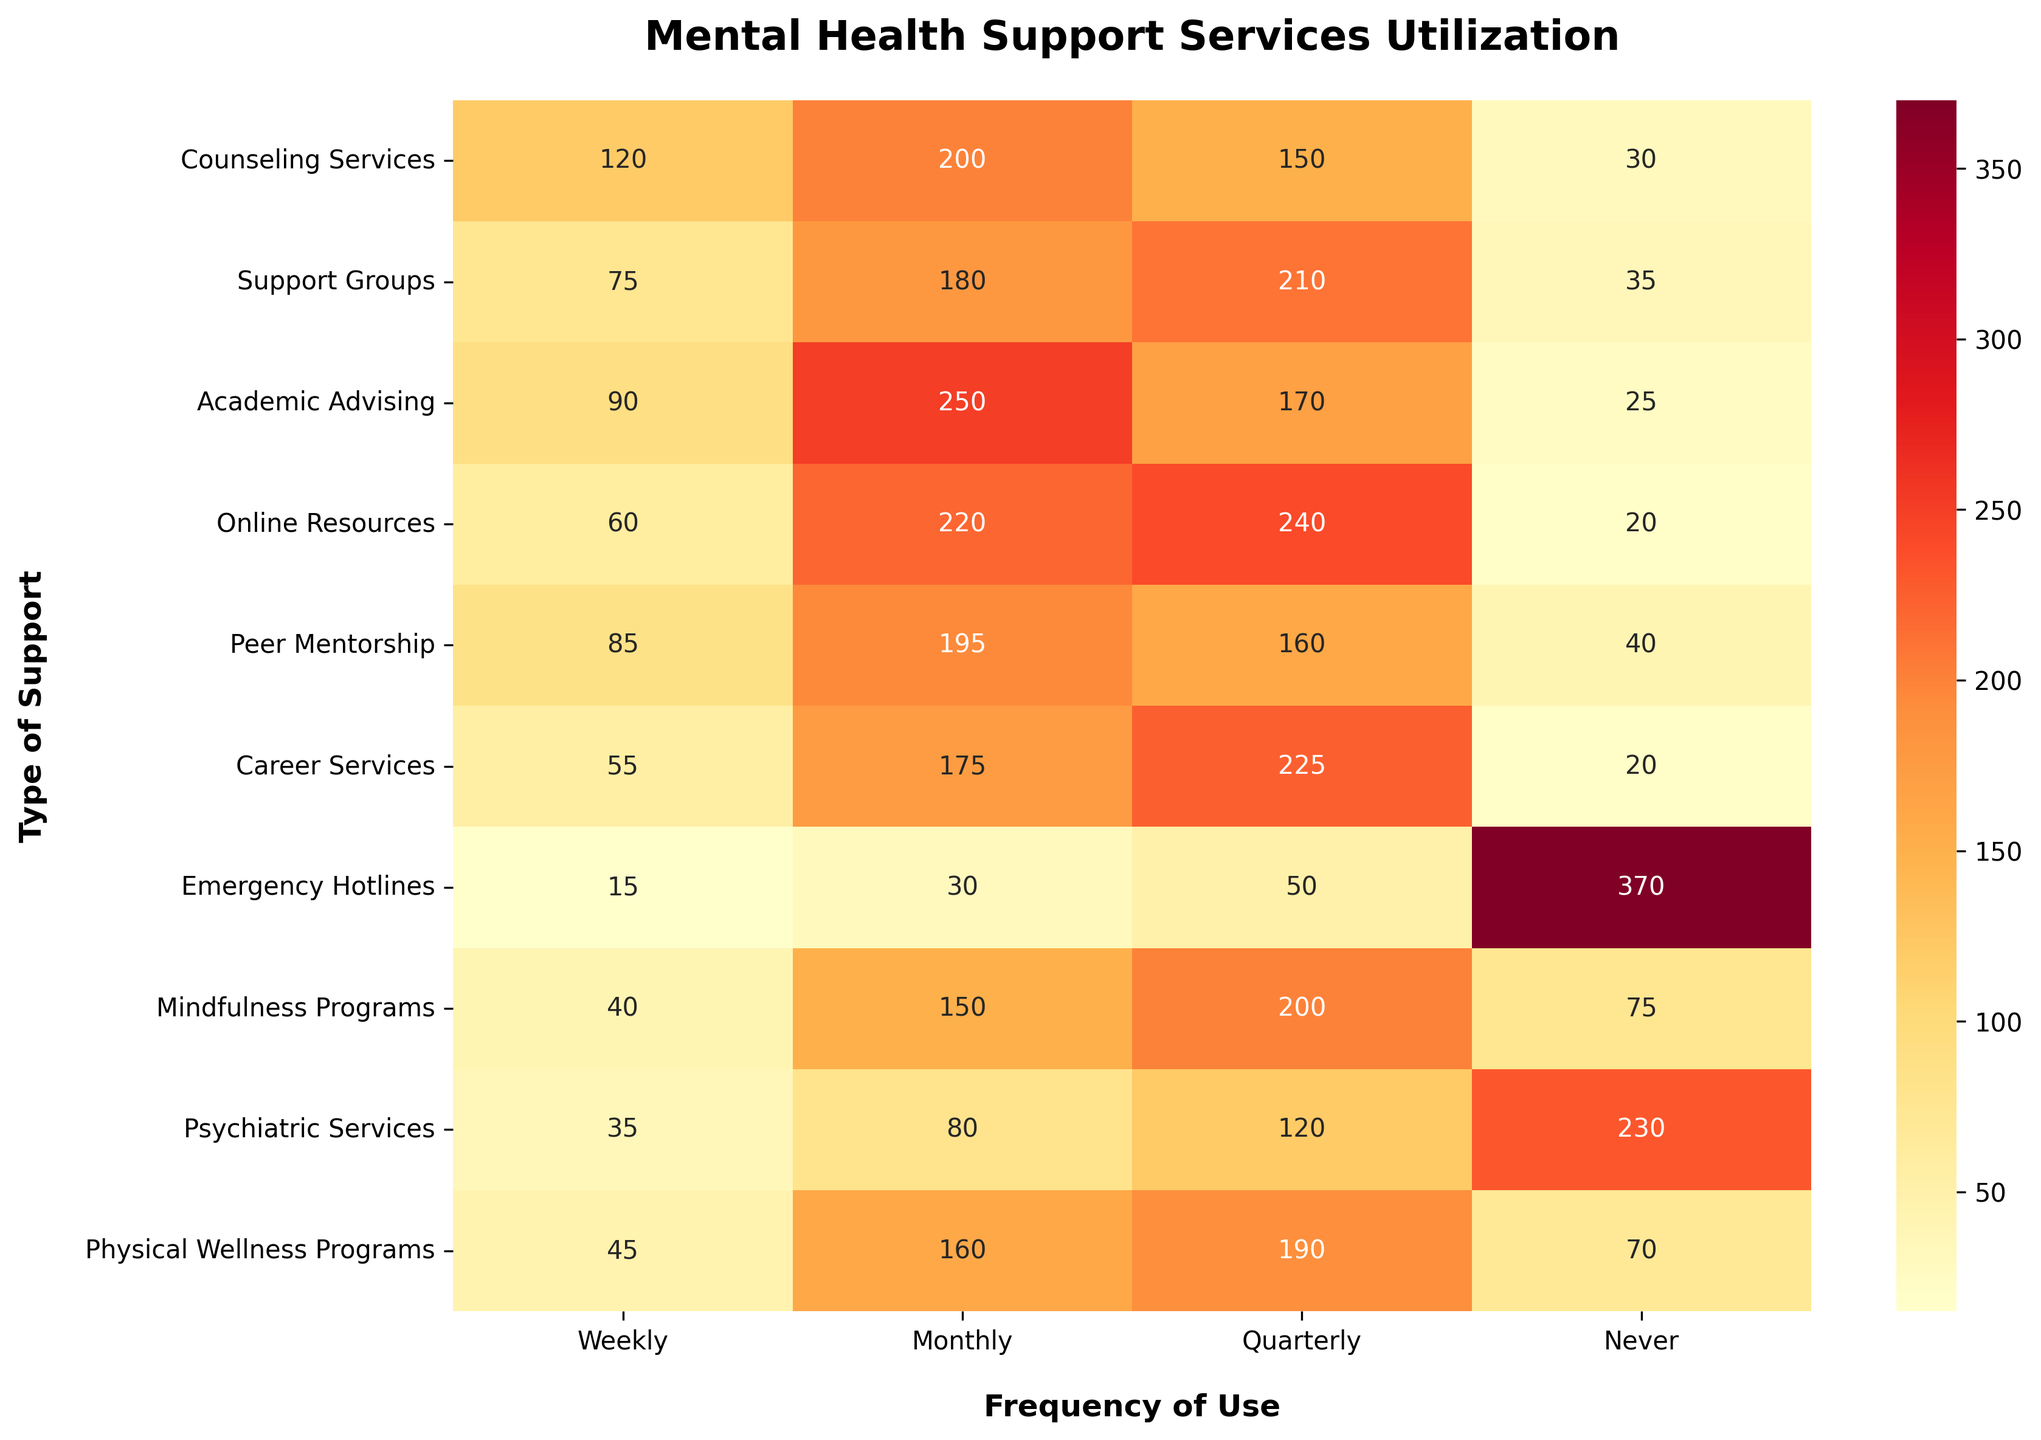What is the total utilization of Counseling Services? To find the total utilization of Counseling Services, sum the values in the Counseling Services row: 120 (Weekly) + 200 (Monthly) + 150 (Quarterly) + 30 (Never) = 500
Answer: 500 Which type of support has the highest number of students who never use it? Look at the 'Never' column and find the highest value: Emergency Hotlines have 370 students who never use it
Answer: Emergency Hotlines For which frequency category does Academic Advising have the highest utilization? Check the values in the Academic Advising row and identify the highest one: 250 in the Monthly column
Answer: Monthly What is the sum of weekly utilizations across all types of support? Sum the values in the Weekly column: 120 (Counseling) + 75 (Support Groups) + 90 (Academic Advising) + 60 (Online Resources) + 85 (Peer Mentorship) + 55 (Career Services) + 15 (Emergency Hotlines) + 40 (Mindfulness Programs) + 35 (Psychiatric Services) + 45 (Physical Wellness Programs) = 620
Answer: 620 Which support type has greater utilization, Counseling Services or Academic Advising, when it comes to quarterly use? Compare the Quarterly values: Counseling Services (150) vs. Academic Advising (170). Since 170 > 150, Academic Advising has greater utilization
Answer: Academic Advising Which support type has the lowest weekly utilization? Compare the values in the Weekly column and identify the lowest one: Emergency Hotlines with 15
Answer: Emergency Hotlines Compare the total number of students who use Support Groups monthly to those who use Counseling Services monthly. Which is higher? Compare Monthly values: Support Groups (180) vs. Counseling Services (200). Since 200 > 180, Counseling Services has higher utilization
Answer: Counseling Services What percentage of students never use Psychiatric Services? First, find the total number of Psychiatric Services users: 35 (Weekly) + 80 (Monthly) + 120 (Quarterly) + 230 (Never) = 465. Next, find the percentage who never use it: (230 / 465) * 100 ≈ 49.46%
Answer: ~49.46% What is the combined utilization of Online Resources and Physical Wellness Programs across all frequencies? Sum the values for both types: Online Resources (60 + 220 + 240 + 20) = 540 and Physical Wellness Programs (45 + 160 + 190 + 70) = 465. Then add these sums: 540 + 465 = 1005
Answer: 1005 